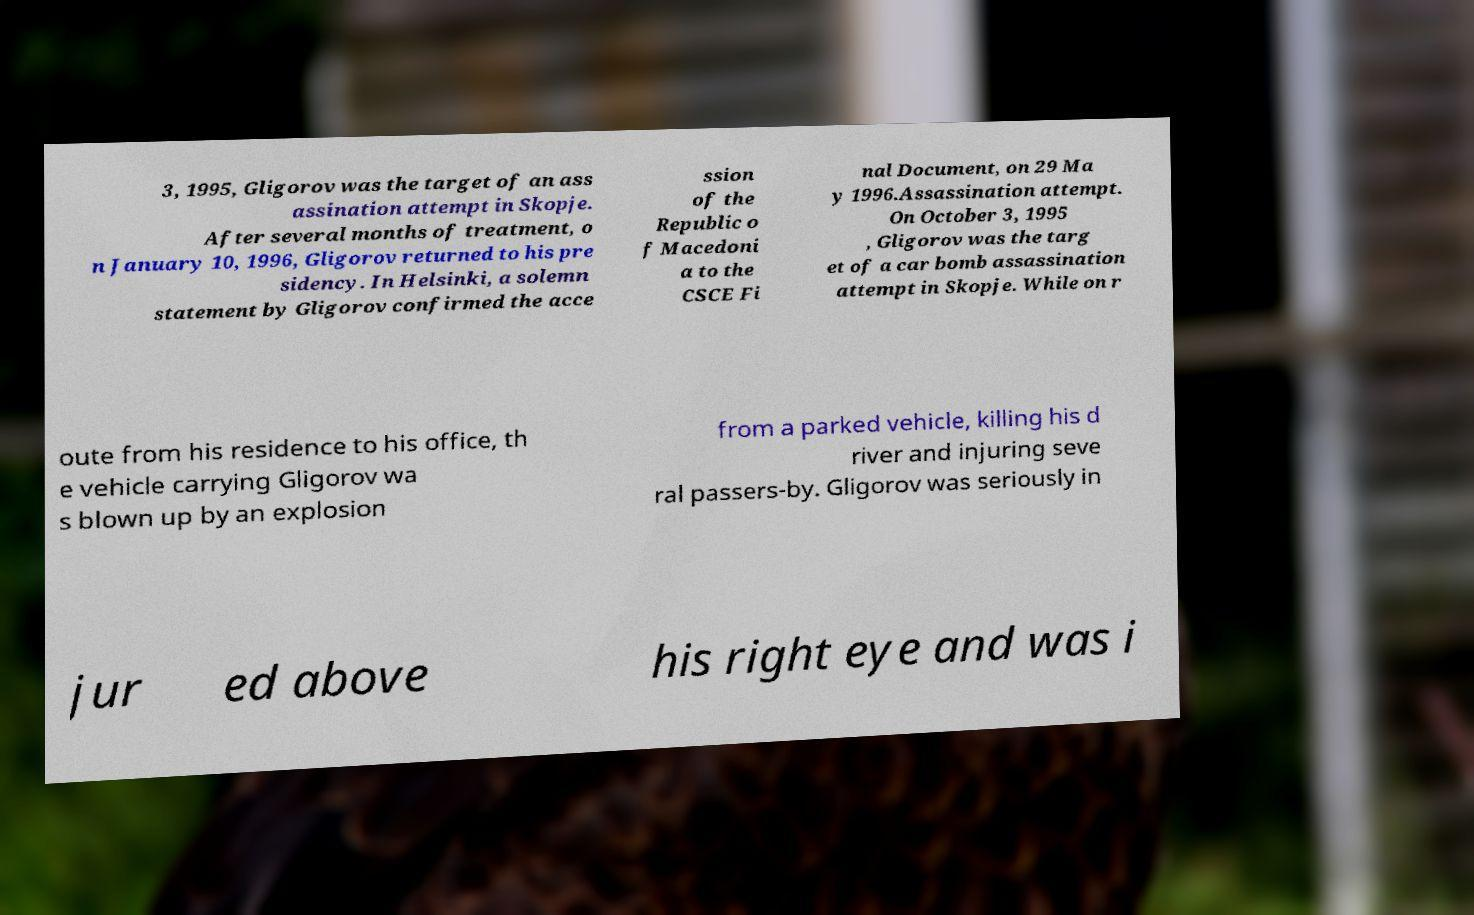Could you assist in decoding the text presented in this image and type it out clearly? 3, 1995, Gligorov was the target of an ass assination attempt in Skopje. After several months of treatment, o n January 10, 1996, Gligorov returned to his pre sidency. In Helsinki, a solemn statement by Gligorov confirmed the acce ssion of the Republic o f Macedoni a to the CSCE Fi nal Document, on 29 Ma y 1996.Assassination attempt. On October 3, 1995 , Gligorov was the targ et of a car bomb assassination attempt in Skopje. While on r oute from his residence to his office, th e vehicle carrying Gligorov wa s blown up by an explosion from a parked vehicle, killing his d river and injuring seve ral passers-by. Gligorov was seriously in jur ed above his right eye and was i 